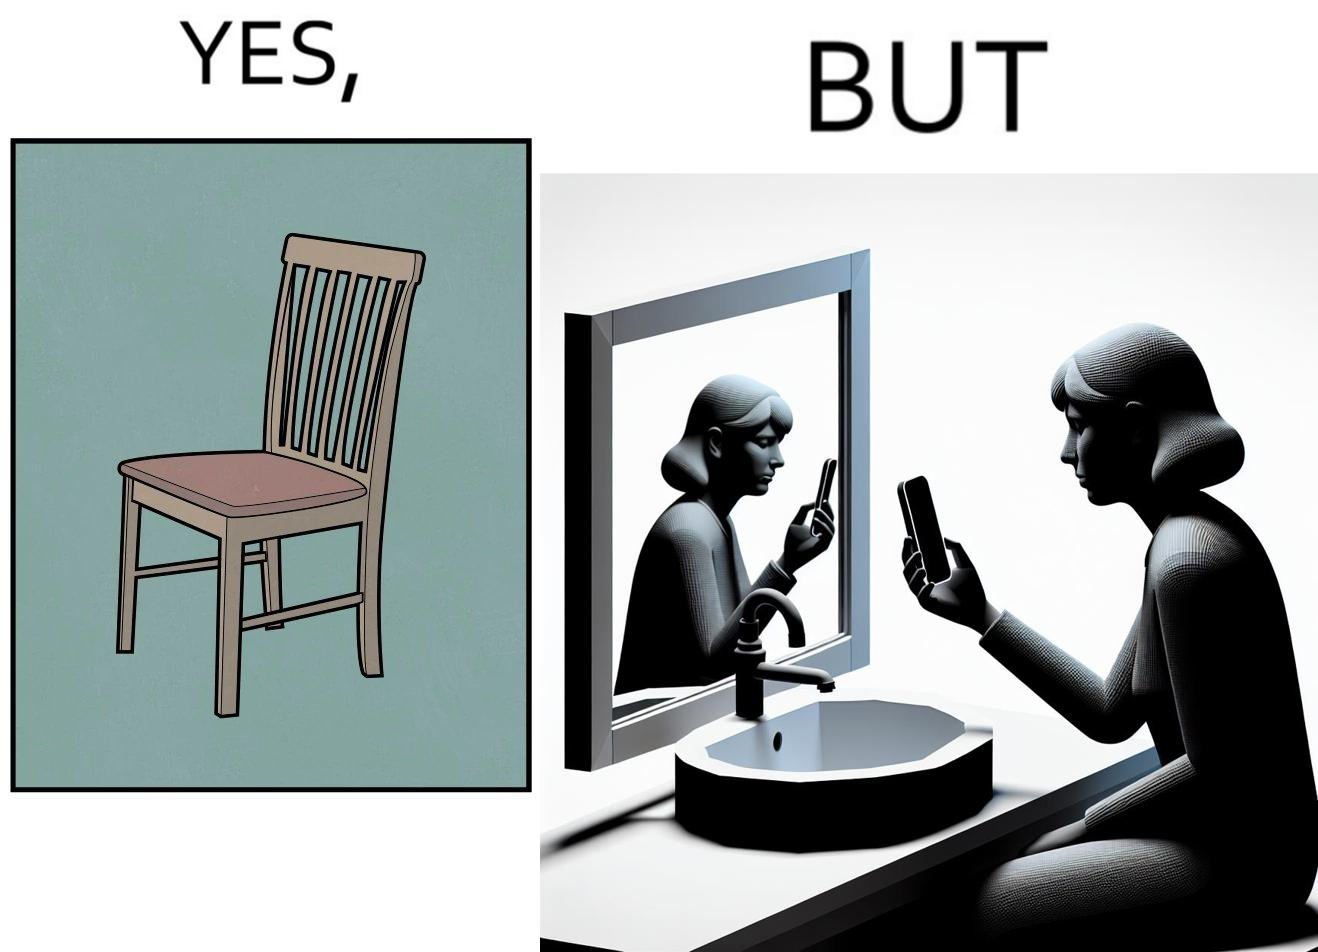Is this a satirical image? Yes, this image is satirical. 